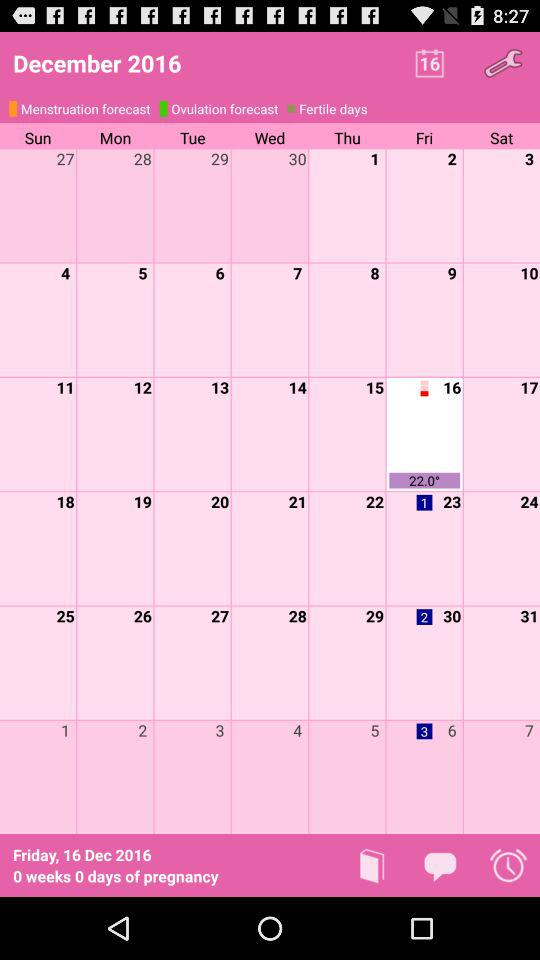What is the temperature today?
Answer the question using a single word or phrase. 22.0° 